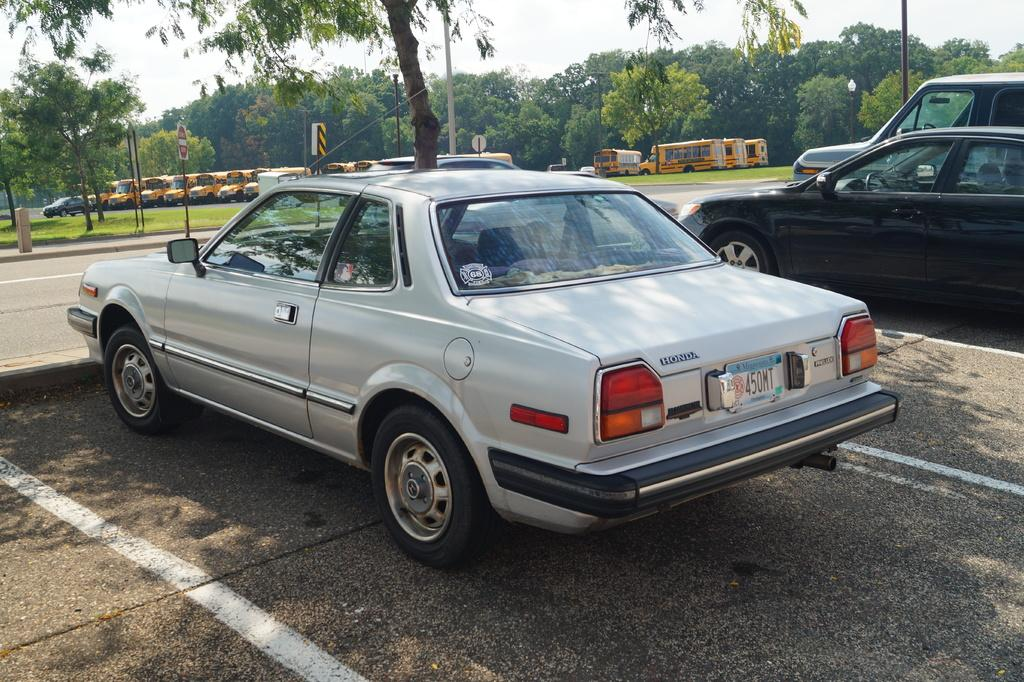What types of objects can be seen in the image? There are vehicles, poles, boards, grass, trees, and a road visible in the image? What can be seen in the background of the image? There is sky visible in the background of the image. What type of fruit is hanging from the poles in the image? There is no fruit hanging from the poles in the image. Can you tell me how many credit cards are visible in the image? There is no mention of credit cards in the image; the facts provided do not include any information about them. 